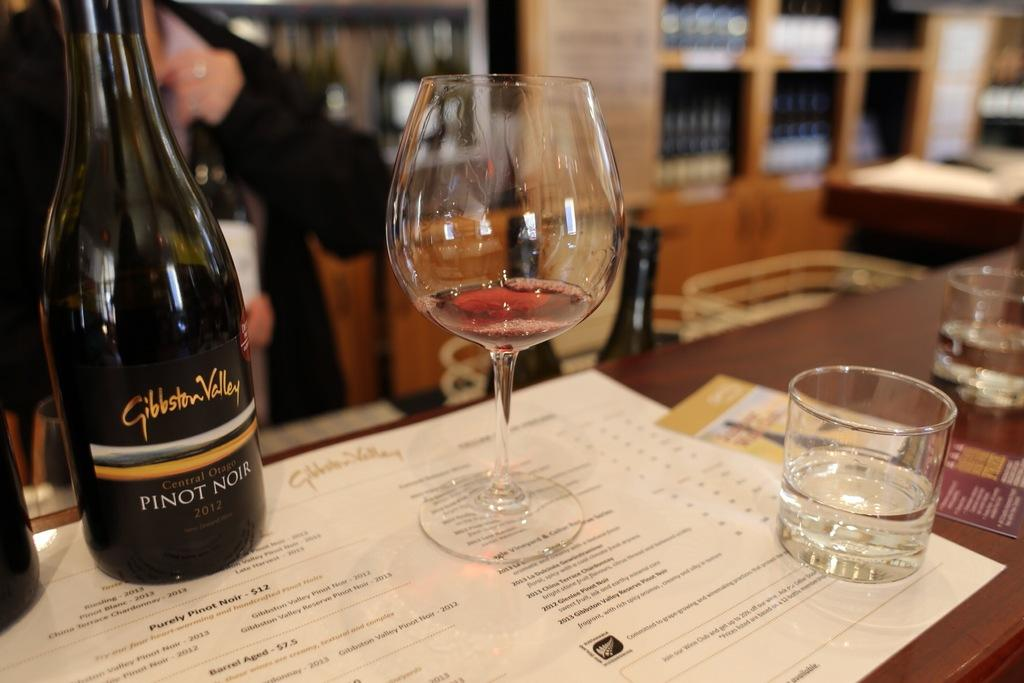What type of glass can be seen in the image? There is a wine glass in the image. What is the wine glass likely to contain? The wine glass is likely to contain wine, as there is a wine bottle in the image. Where are the wine glass and wine bottle located? Both the wine glass and wine bottle are on a table. How many mittens are being used to stitch the pigs in the image? There are no mittens, stitching, or pigs present in the image. 